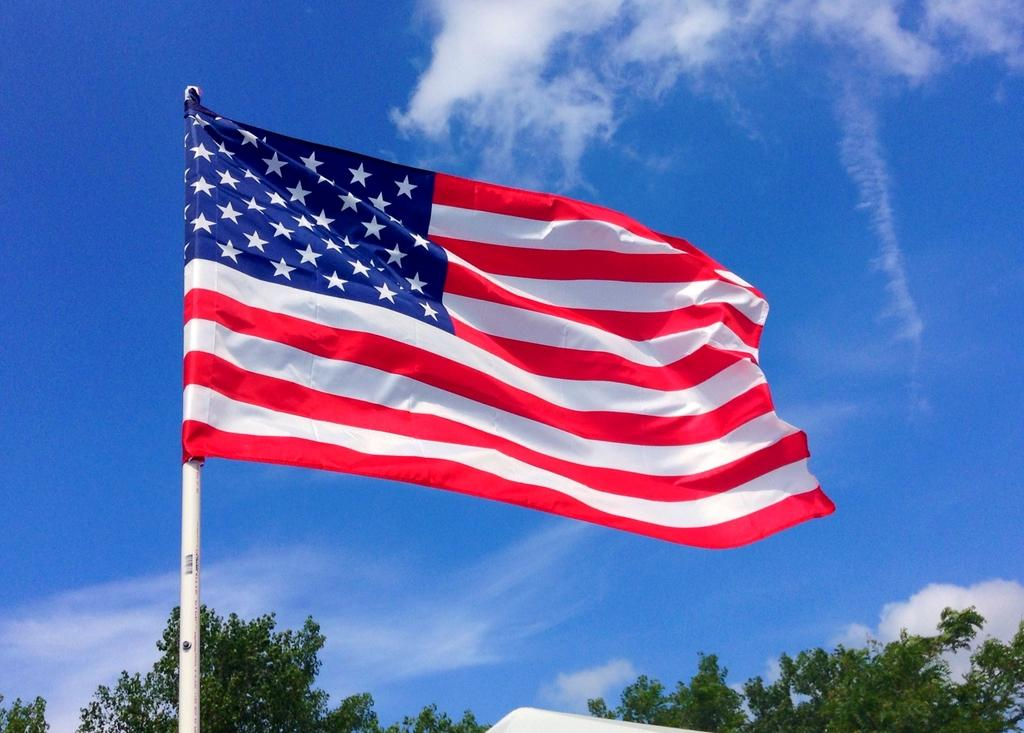What is the main object in the image? There is a flag in the image. What is the flag attached to? The flag is attached to a pole in the image. What type of vegetation can be seen at the bottom of the image? Branches and leaves are visible at the bottom of the image. What can be seen in the background of the image? There is sky visible in the background of the image, and clouds are present in the sky. What type of ornament is hanging from the flag in the image? There is no ornament hanging from the flag in the image; it only features the flag and pole. 